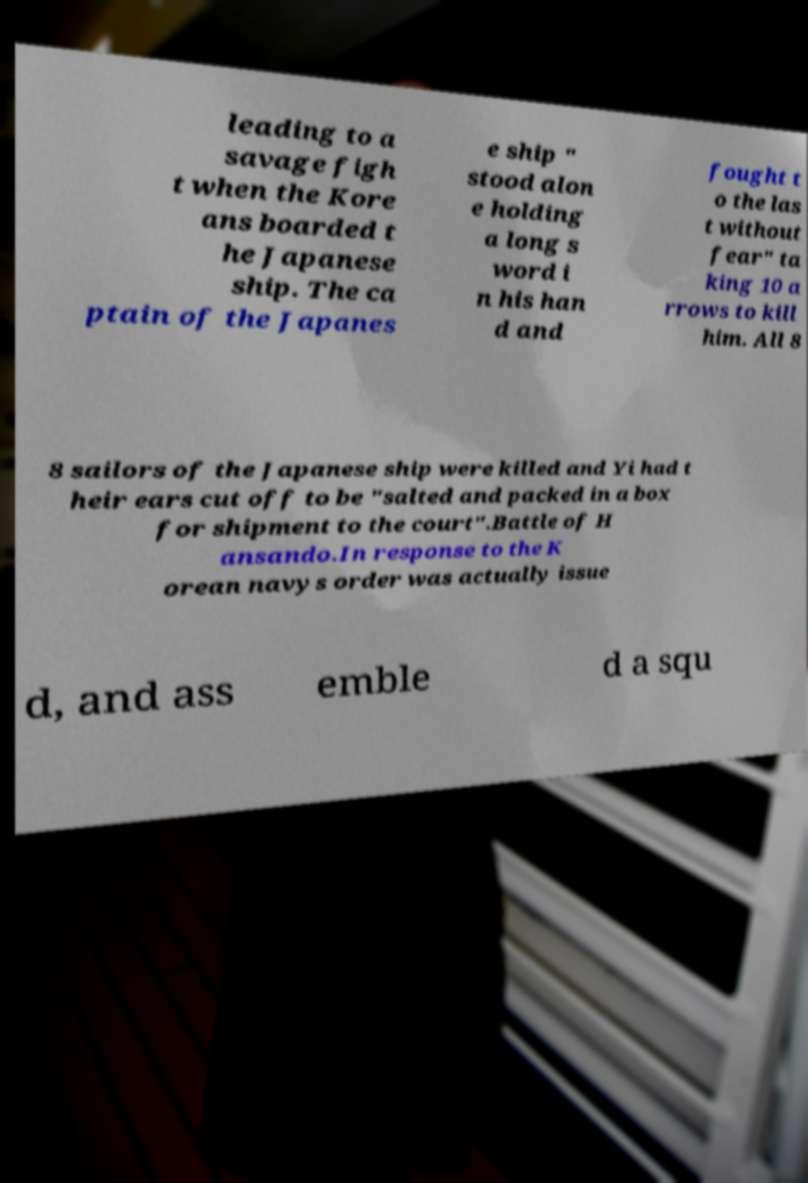Could you assist in decoding the text presented in this image and type it out clearly? leading to a savage figh t when the Kore ans boarded t he Japanese ship. The ca ptain of the Japanes e ship " stood alon e holding a long s word i n his han d and fought t o the las t without fear" ta king 10 a rrows to kill him. All 8 8 sailors of the Japanese ship were killed and Yi had t heir ears cut off to be "salted and packed in a box for shipment to the court".Battle of H ansando.In response to the K orean navys order was actually issue d, and ass emble d a squ 